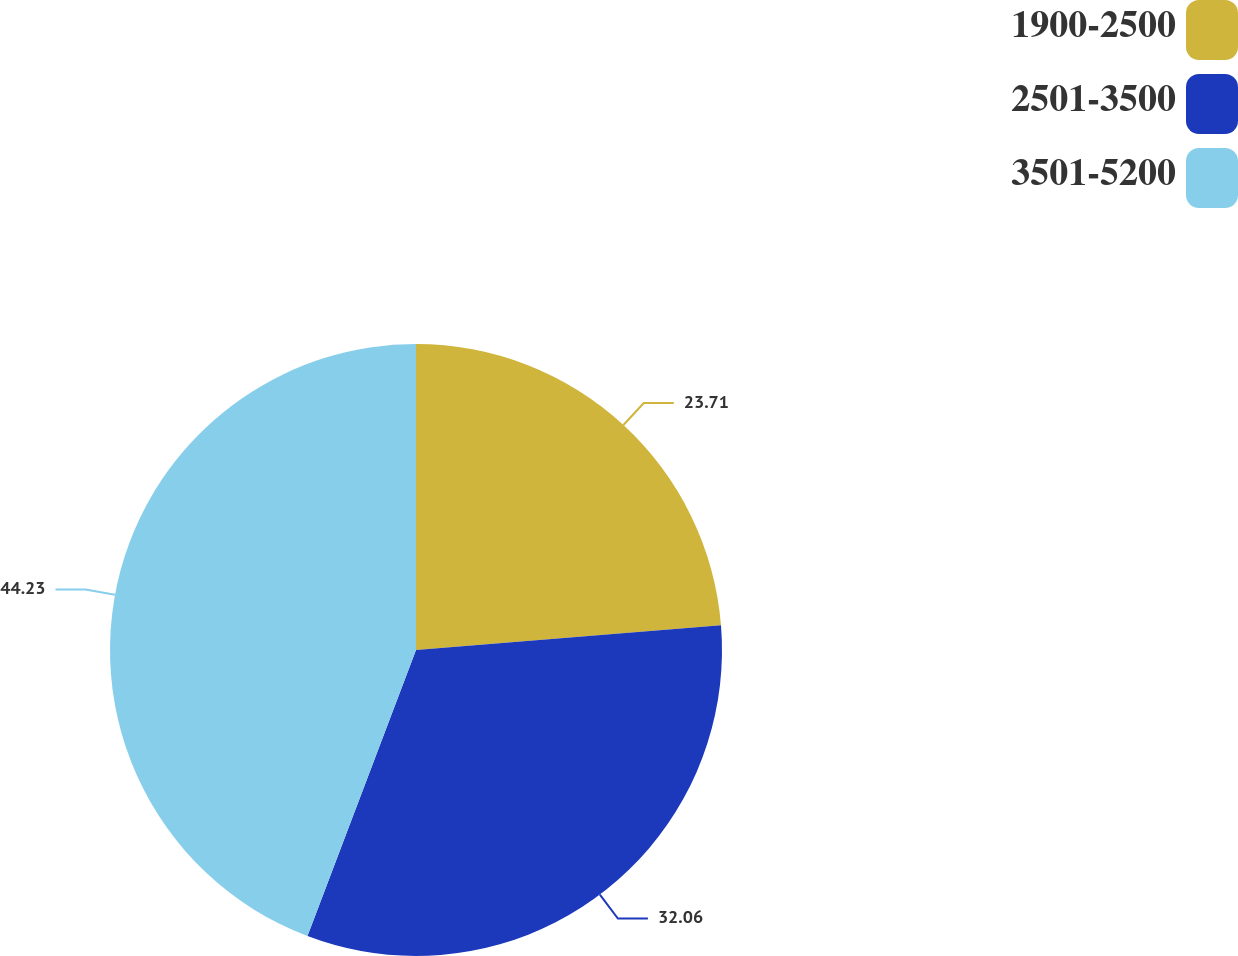Convert chart to OTSL. <chart><loc_0><loc_0><loc_500><loc_500><pie_chart><fcel>1900-2500<fcel>2501-3500<fcel>3501-5200<nl><fcel>23.71%<fcel>32.06%<fcel>44.23%<nl></chart> 